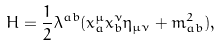Convert formula to latex. <formula><loc_0><loc_0><loc_500><loc_500>H = \frac { 1 } { 2 } \lambda ^ { a b } ( x _ { a } ^ { \mu } x _ { b } ^ { \nu } \eta _ { \mu \nu } + m _ { a b } ^ { 2 } ) ,</formula> 